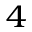Convert formula to latex. <formula><loc_0><loc_0><loc_500><loc_500>^ { 4 }</formula> 